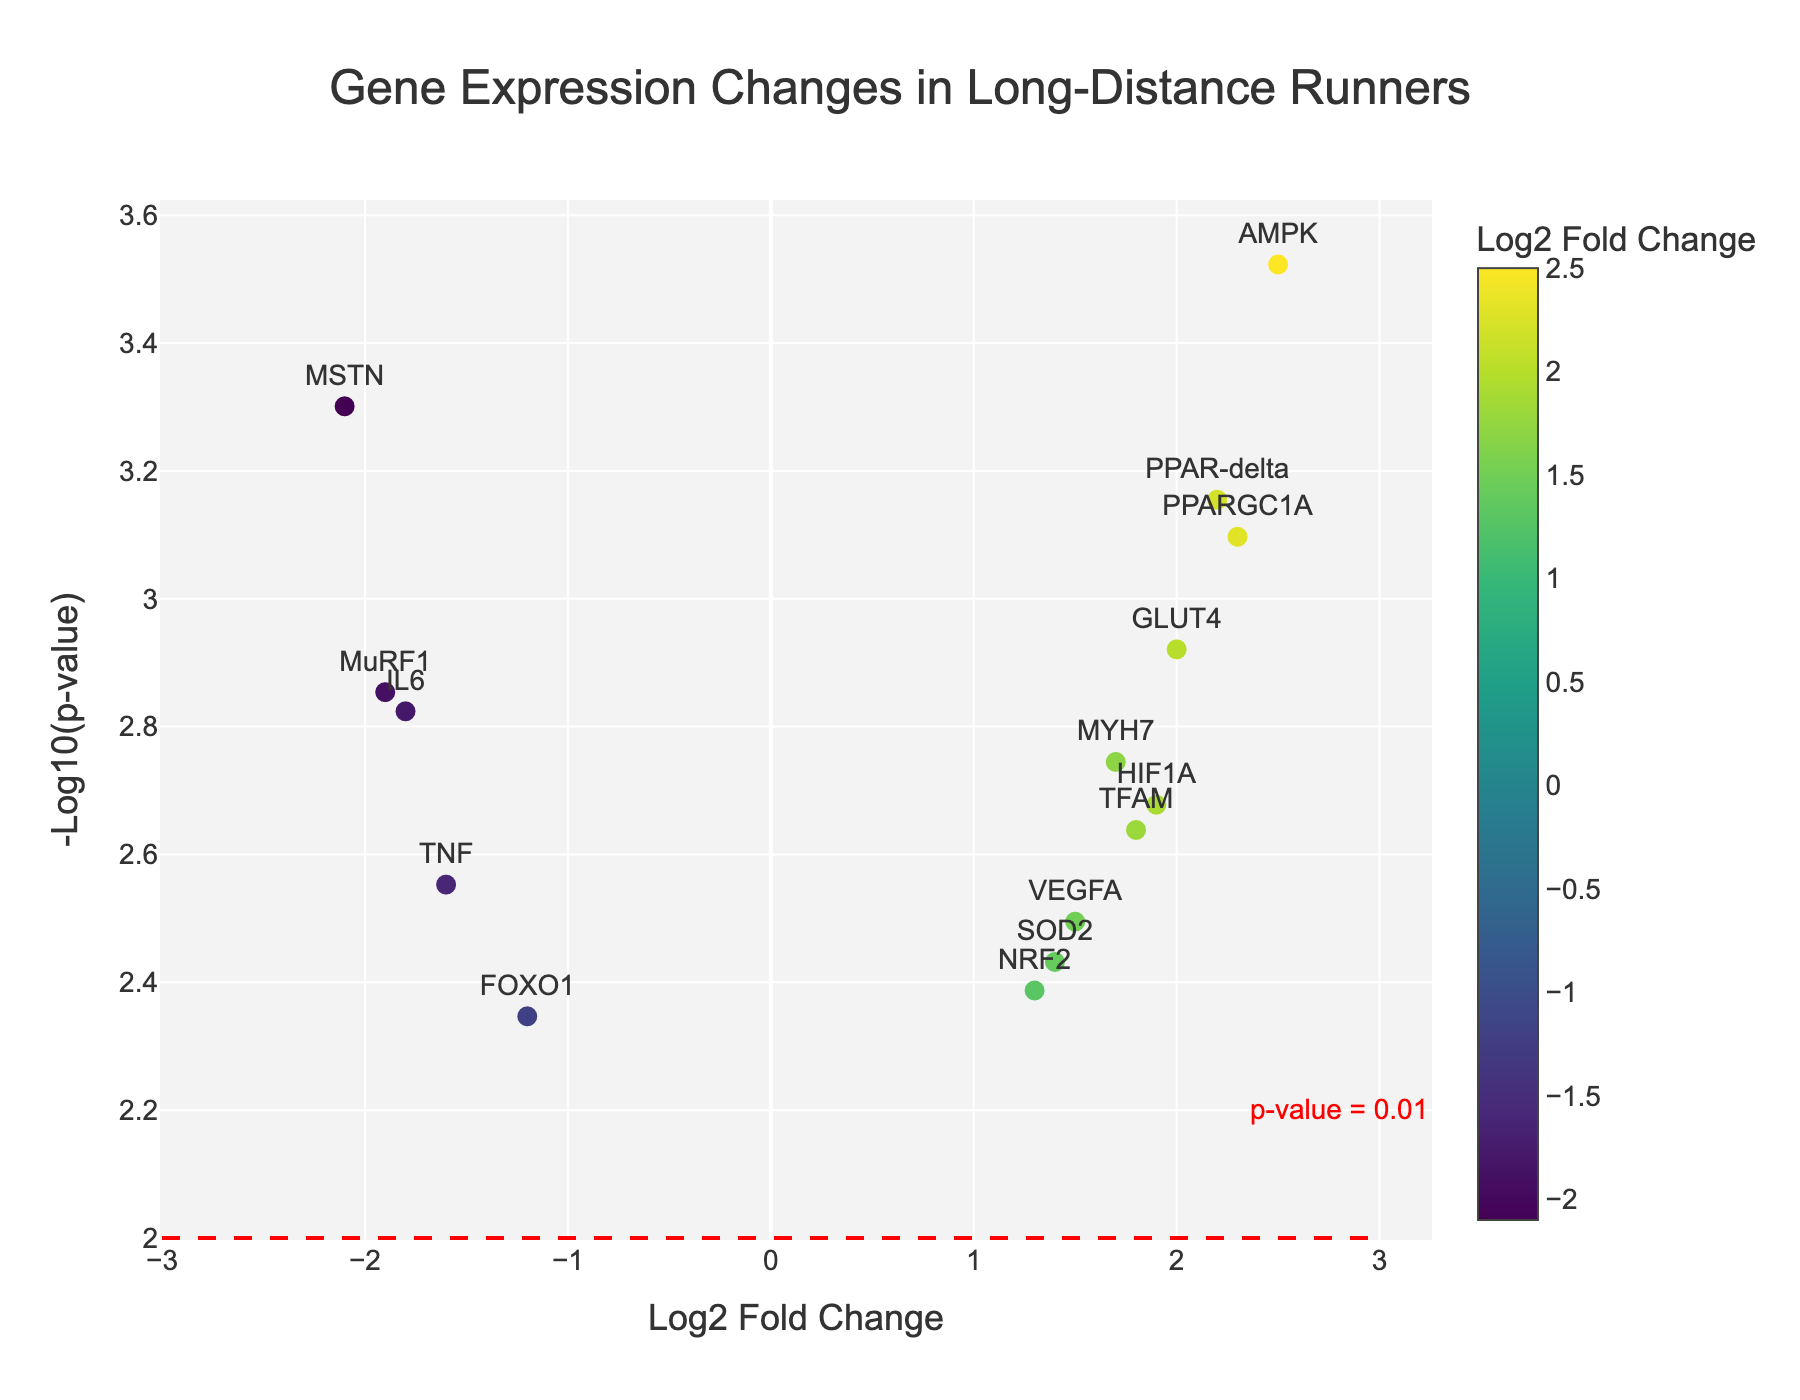Which gene has the highest log2 fold change? The log2 fold change value is found on the x-axis. The gene with the highest value in this plot is AMPK, with a log2 fold change of 2.5.
Answer: AMPK What does the y-axis represent in this plot? The y-axis represents the -log10 of the p-values for each gene. Larger values on this axis indicate smaller p-values (more significant expression changes).
Answer: -log10(p-value) How many genes have a log2 fold change greater than 1? Identifying the genes with a log2 fold change greater than 1 involves counting the data points to the right of 1 on the x-axis. These genes are PPARGC1A, VEGFA, HIF1A, AMPK, MYH7, GLUT4, SOD2, TFAM, NRF2, and PPAR-delta, totaling 10 genes.
Answer: 10 Which gene has the lowest p-value? Lower p-values are represented by higher values on the y-axis. The gene with the highest y-value (-log10(p-value)) in this plot is AMPK, with a y-value of approximately 3.477. Checking the data, AMPK has a p-value of 0.0003, which is the lowest.
Answer: AMPK How many genes are below the p-value threshold of 0.01? The threshold line at -log10(p-value) = 2 helps find the genes below this p-value threshold. Counting the points above this line, there are 14 genes meeting this criterion.
Answer: 14 Which gene is most downregulated? Downregulated genes have negative log2 fold change values. The gene with the most negative value is MSTN, with a log2 fold change of -2.1.
Answer: MSTN Compare the gene with the largest positive fold change to the one with the largest negative fold change. What are their p-values? The gene with the largest positive log2 fold change is AMPK (log2 fold change = 2.5), and the gene with the most significant negative change is MSTN (log2 fold change = -2.1). Their p-values are 0.0003 and 0.0005, respectively.
Answer: 0.0003 and 0.0005 How does the expression of IL6 compare to that of VEGFA? IL6 has a log2 fold change of -1.8, meaning it is downregulated, while VEGFA has a log2 fold change of 1.5, meaning it is upregulated.
Answer: Downregulated vs. Upregulated Which gene has the highest combined significance and change? Combined significance and change would be indicated by high y (high -log10(p-value), hence low p-value) and extreme x (log2 fold change) values. AMPK stands out as the gene with both the highest log2 fold change and a very low p-value.
Answer: AMPK 